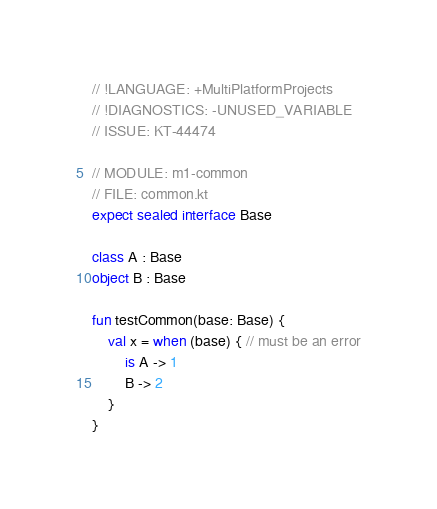<code> <loc_0><loc_0><loc_500><loc_500><_Kotlin_>// !LANGUAGE: +MultiPlatformProjects
// !DIAGNOSTICS: -UNUSED_VARIABLE
// ISSUE: KT-44474

// MODULE: m1-common
// FILE: common.kt
expect sealed interface Base

class A : Base
object B : Base

fun testCommon(base: Base) {
    val x = when (base) { // must be an error
        is A -> 1
        B -> 2
    }
}
</code> 